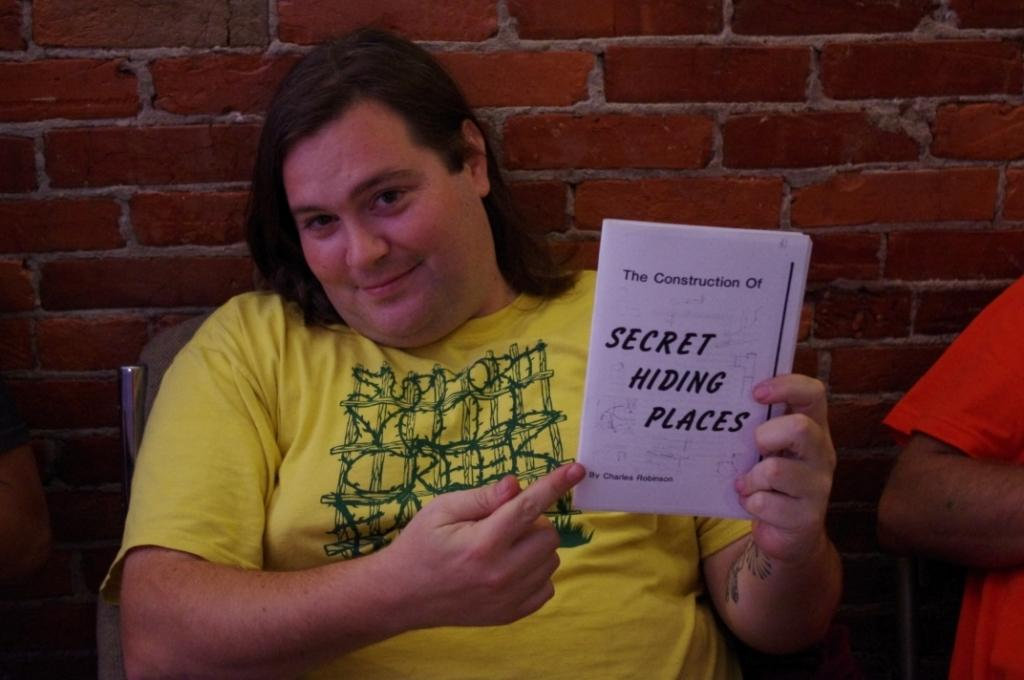<image>
Summarize the visual content of the image. A person in a yellow shirt is holding a pamphlet that says Secret Hiding Places. 